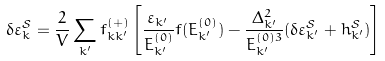<formula> <loc_0><loc_0><loc_500><loc_500>\delta \varepsilon _ { k } ^ { \mathcal { S } } = \frac { 2 } { V } \sum _ { k ^ { \prime } } f ^ { ( + ) } _ { k k ^ { \prime } } \left [ \frac { \varepsilon _ { k ^ { \prime } } } { E _ { k ^ { \prime } } ^ { ( 0 ) } } f ( E _ { k ^ { \prime } } ^ { ( 0 ) } ) - \frac { \Delta _ { k ^ { \prime } } ^ { 2 } } { E _ { k ^ { \prime } } ^ { ( 0 ) 3 } } ( \delta \varepsilon _ { k ^ { \prime } } ^ { \mathcal { S } } + h _ { k ^ { \prime } } ^ { \mathcal { S } } ) \right ]</formula> 